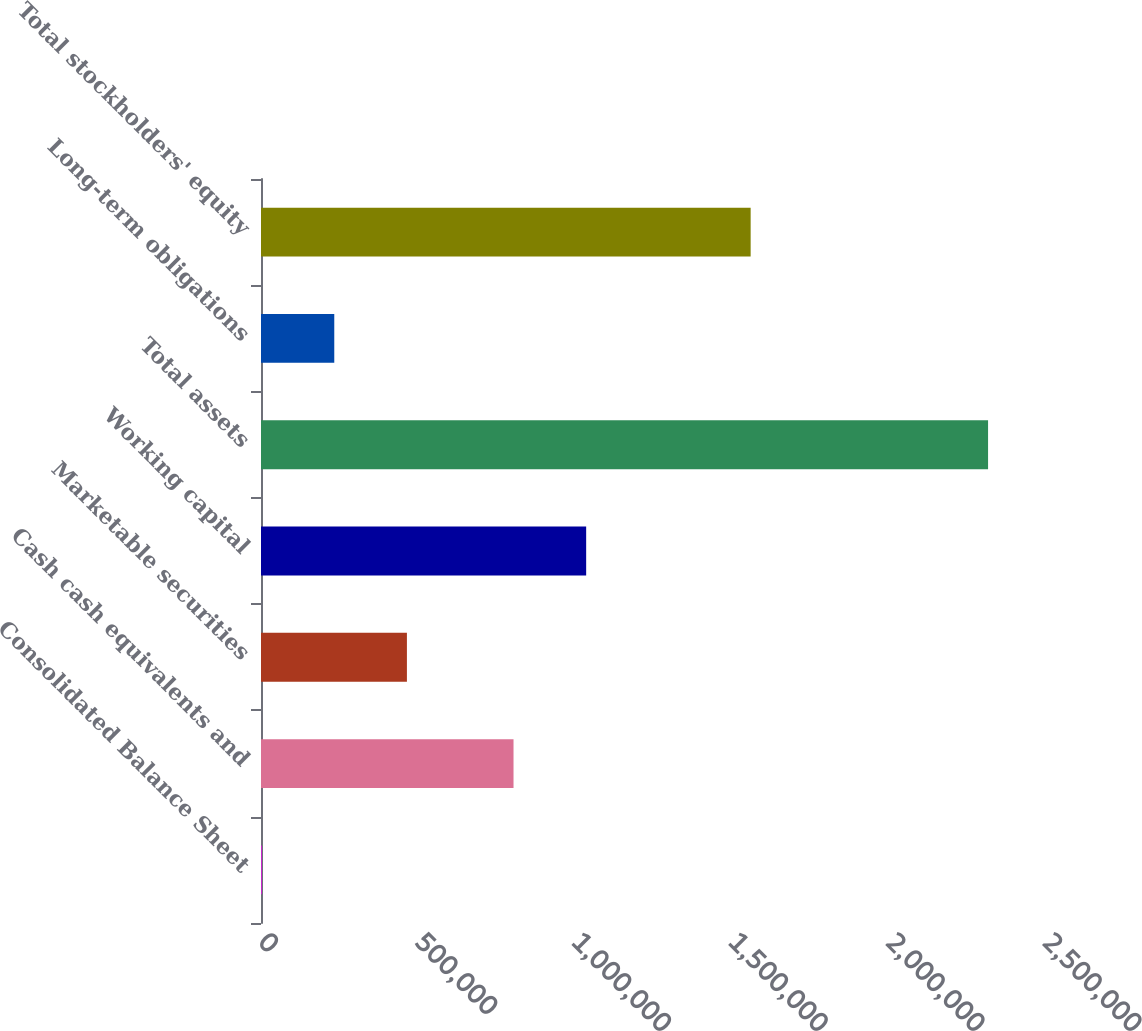Convert chart. <chart><loc_0><loc_0><loc_500><loc_500><bar_chart><fcel>Consolidated Balance Sheet<fcel>Cash cash equivalents and<fcel>Marketable securities<fcel>Working capital<fcel>Total assets<fcel>Long-term obligations<fcel>Total stockholders' equity<nl><fcel>1999<fcel>805220<fcel>465290<fcel>1.03687e+06<fcel>2.31846e+06<fcel>233645<fcel>1.56139e+06<nl></chart> 